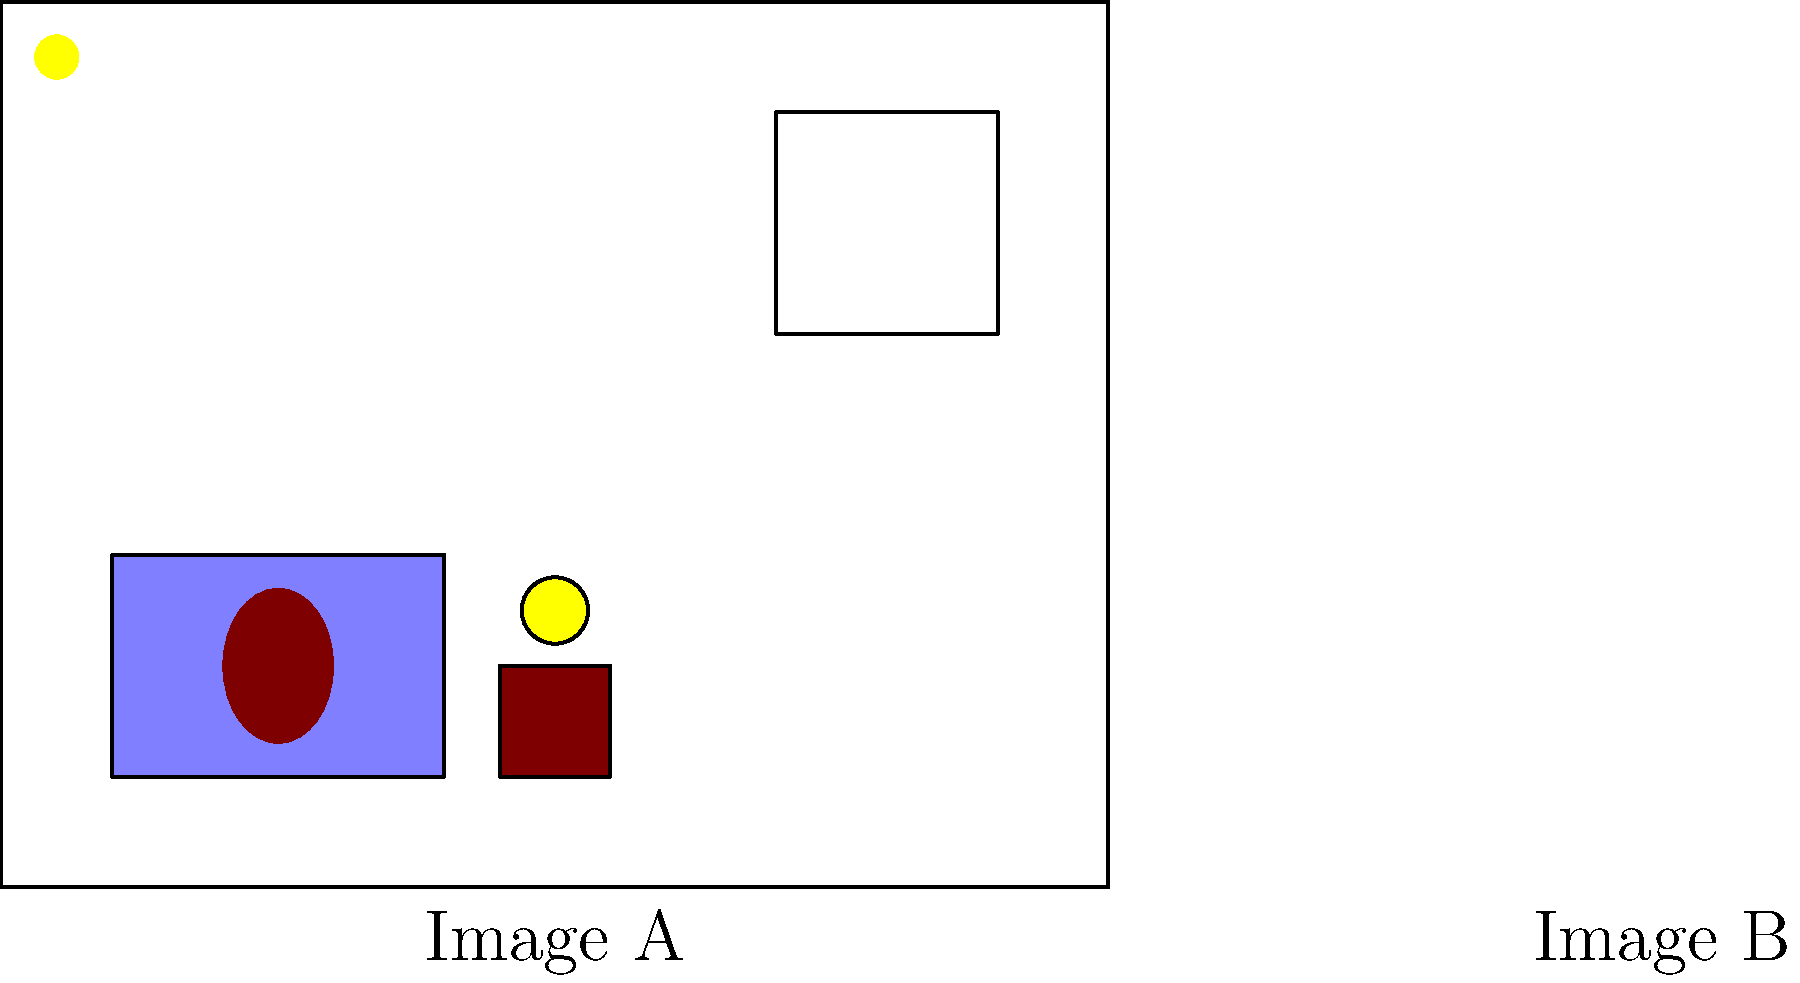Look carefully at the two images of a child's bedroom (Image A and Image B). Can you spot the difference between them? What calming element has been added to Image B that is not present in Image A? To find the difference between the two images, we need to carefully examine each element in both rooms:

1. Both images show a child's bedroom with similar layout and furniture.
2. In both images, we can see:
   a) A bed with a light blue cover
   b) A nightstand with a lamp
   c) A teddy bear on the bed
   d) A window with curtains

3. The key difference is in the top left corner of Image B:
   There is a small, circular yellow object that is not present in Image A.

4. This object represents a night light, which is often used to provide a soft, comforting glow for children who may be afraid of the dark.

5. Night lights are considered calming elements in a child's bedroom, as they can help reduce anxiety and create a sense of security during bedtime.

Therefore, the calming element added to Image B that is not present in Image A is a night light.
Answer: Night light 